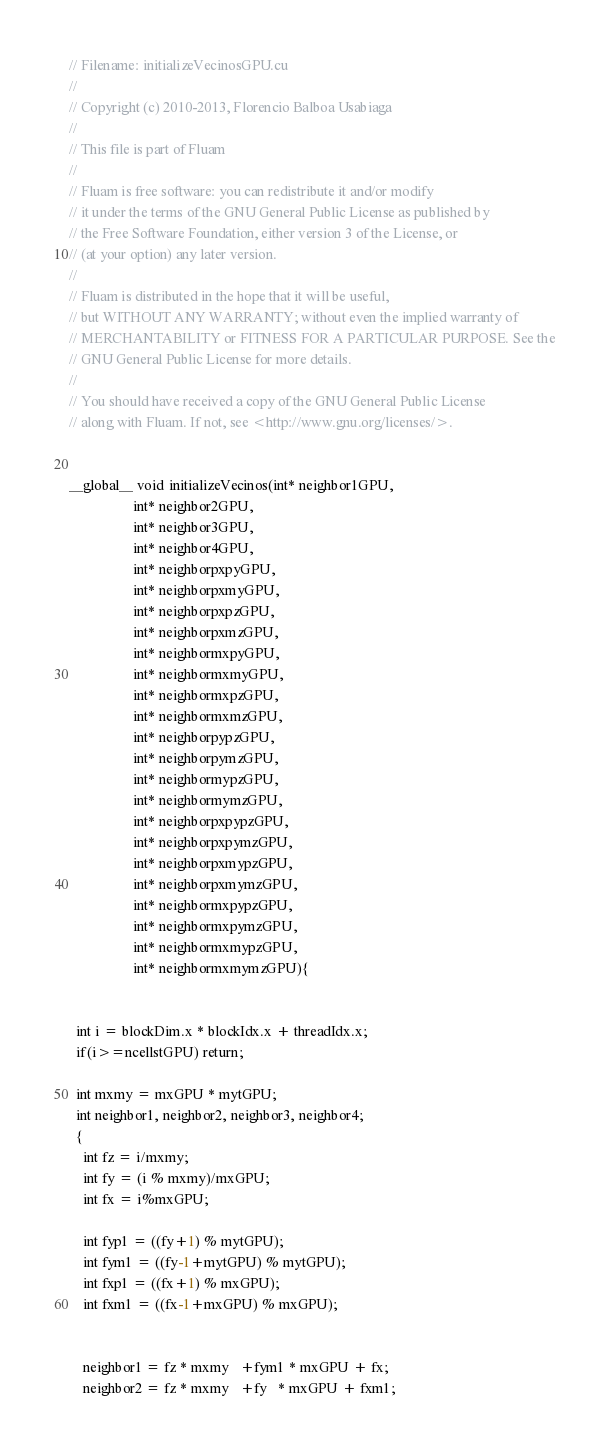Convert code to text. <code><loc_0><loc_0><loc_500><loc_500><_Cuda_>// Filename: initializeVecinosGPU.cu
//
// Copyright (c) 2010-2013, Florencio Balboa Usabiaga
//
// This file is part of Fluam
//
// Fluam is free software: you can redistribute it and/or modify
// it under the terms of the GNU General Public License as published by
// the Free Software Foundation, either version 3 of the License, or
// (at your option) any later version.
//
// Fluam is distributed in the hope that it will be useful,
// but WITHOUT ANY WARRANTY; without even the implied warranty of
// MERCHANTABILITY or FITNESS FOR A PARTICULAR PURPOSE. See the
// GNU General Public License for more details.
//
// You should have received a copy of the GNU General Public License
// along with Fluam. If not, see <http://www.gnu.org/licenses/>.


__global__ void initializeVecinos(int* neighbor1GPU, 
				  int* neighbor2GPU, 
				  int* neighbor3GPU, 
				  int* neighbor4GPU, 
				  int* neighborpxpyGPU, 
				  int* neighborpxmyGPU, 
				  int* neighborpxpzGPU, 
				  int* neighborpxmzGPU,
				  int* neighbormxpyGPU, 
				  int* neighbormxmyGPU, 
				  int* neighbormxpzGPU, 
				  int* neighbormxmzGPU,
				  int* neighborpypzGPU, 
				  int* neighborpymzGPU, 
				  int* neighbormypzGPU, 
				  int* neighbormymzGPU,
				  int* neighborpxpypzGPU, 
				  int* neighborpxpymzGPU, 
				  int* neighborpxmypzGPU, 
				  int* neighborpxmymzGPU,
				  int* neighbormxpypzGPU, 
				  int* neighbormxpymzGPU, 
				  int* neighbormxmypzGPU, 
				  int* neighbormxmymzGPU){

  
  int i = blockDim.x * blockIdx.x + threadIdx.x;
  if(i>=ncellstGPU) return;

  int mxmy = mxGPU * mytGPU; 
  int neighbor1, neighbor2, neighbor3, neighbor4;
  {
    int fz = i/mxmy;
    int fy = (i % mxmy)/mxGPU;
    int fx = i%mxGPU;
     
    int fyp1 = ((fy+1) % mytGPU);
    int fym1 = ((fy-1+mytGPU) % mytGPU);
    int fxp1 = ((fx+1) % mxGPU);
    int fxm1 = ((fx-1+mxGPU) % mxGPU);
    
    
    neighbor1 = fz * mxmy   +fym1 * mxGPU + fx;
    neighbor2 = fz * mxmy   +fy   * mxGPU + fxm1;</code> 